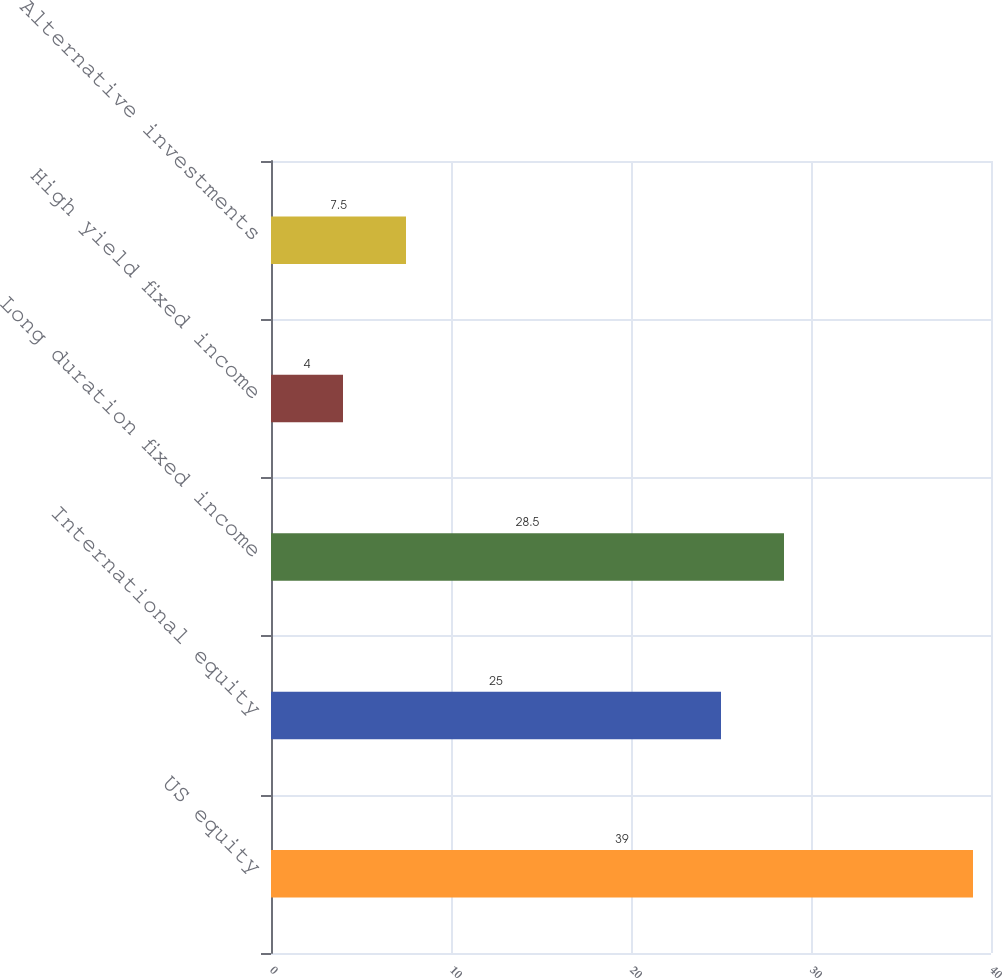<chart> <loc_0><loc_0><loc_500><loc_500><bar_chart><fcel>US equity<fcel>International equity<fcel>Long duration fixed income<fcel>High yield fixed income<fcel>Alternative investments<nl><fcel>39<fcel>25<fcel>28.5<fcel>4<fcel>7.5<nl></chart> 